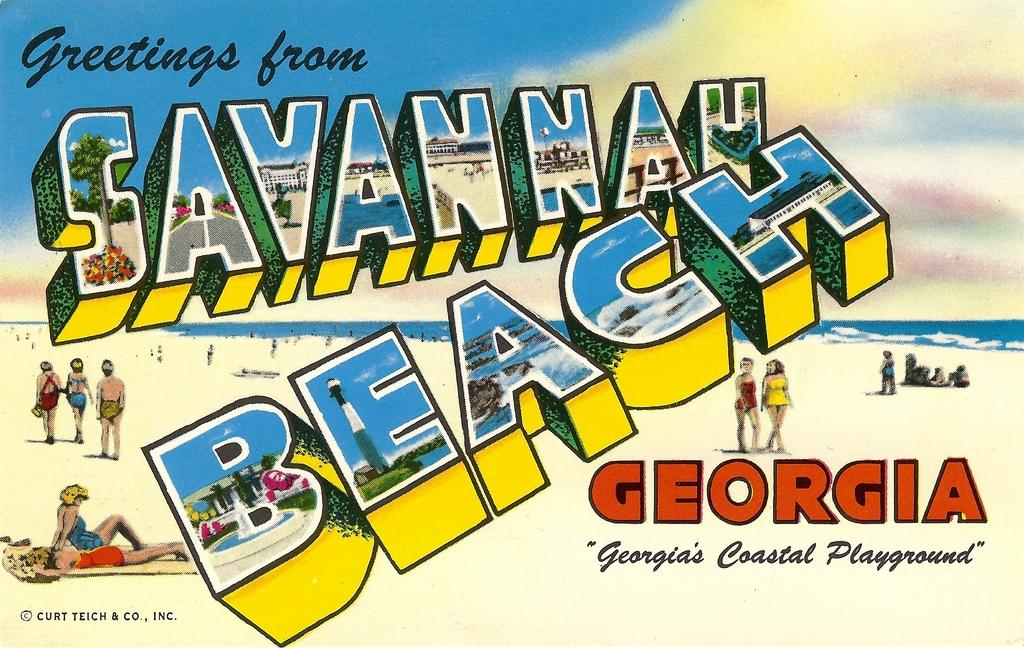<image>
Offer a succinct explanation of the picture presented. A postcard from Savannah Beach Georgia with various cartoon like people walking on a beach. 